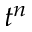Convert formula to latex. <formula><loc_0><loc_0><loc_500><loc_500>t ^ { n }</formula> 